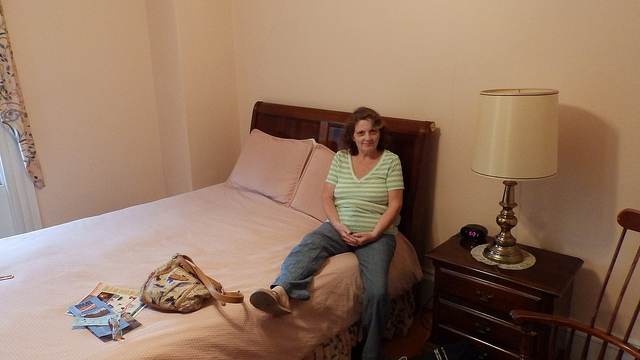<image>Where are the red net stockings? It is unknown where the red net stockings are. They may be in a drawer or under the bed. What pattern is on the blanket? I don't know what pattern is on the blanket. It could be solid or plain. Where are the red net stockings? There are no red net stockings in the image. What pattern is on the blanket? I don't know what pattern is on the blanket. It can be solid, plain or none. 